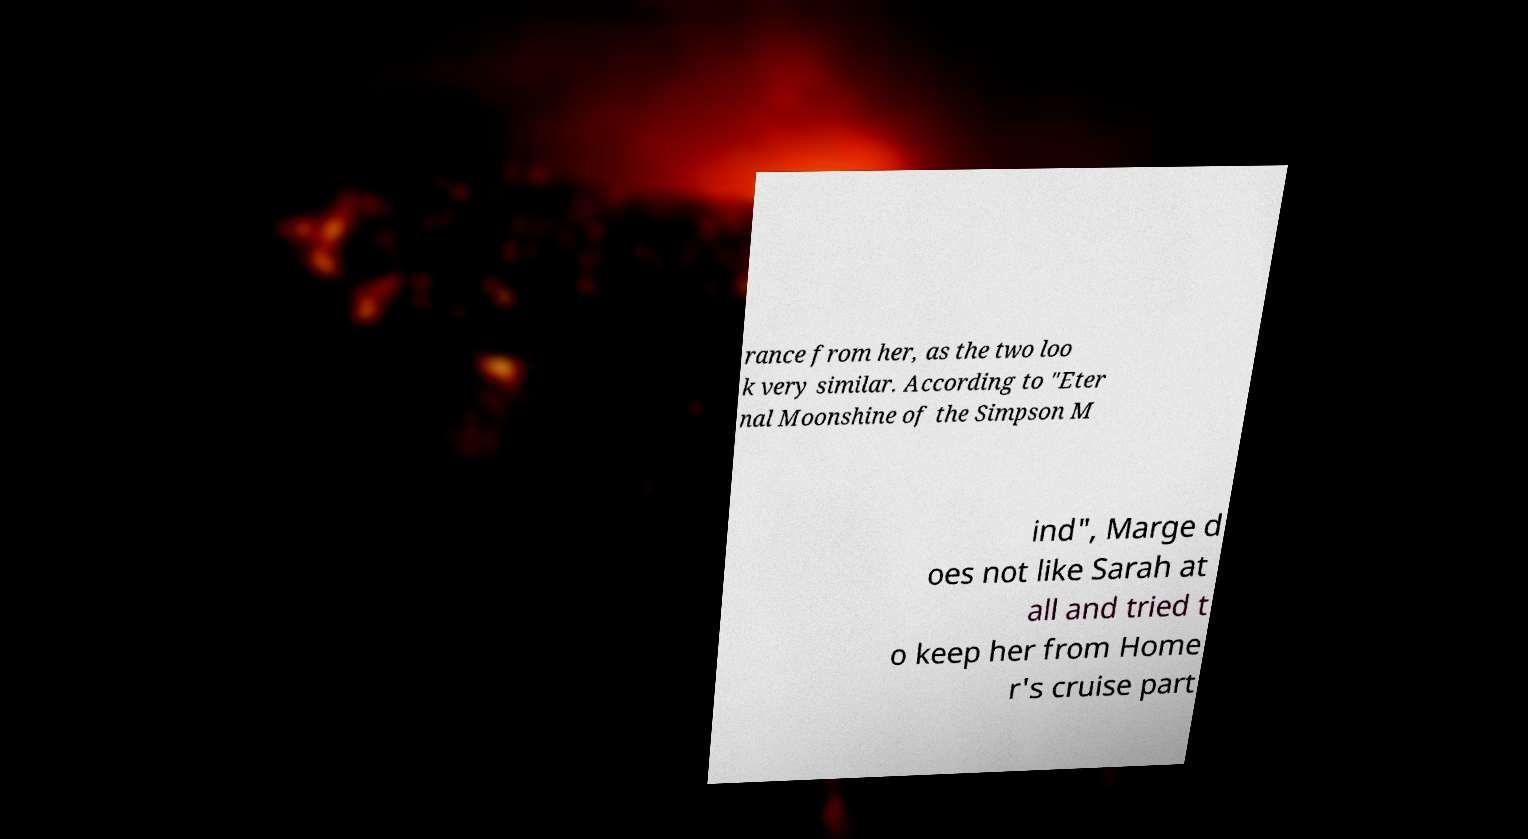Could you assist in decoding the text presented in this image and type it out clearly? rance from her, as the two loo k very similar. According to "Eter nal Moonshine of the Simpson M ind", Marge d oes not like Sarah at all and tried t o keep her from Home r's cruise part 